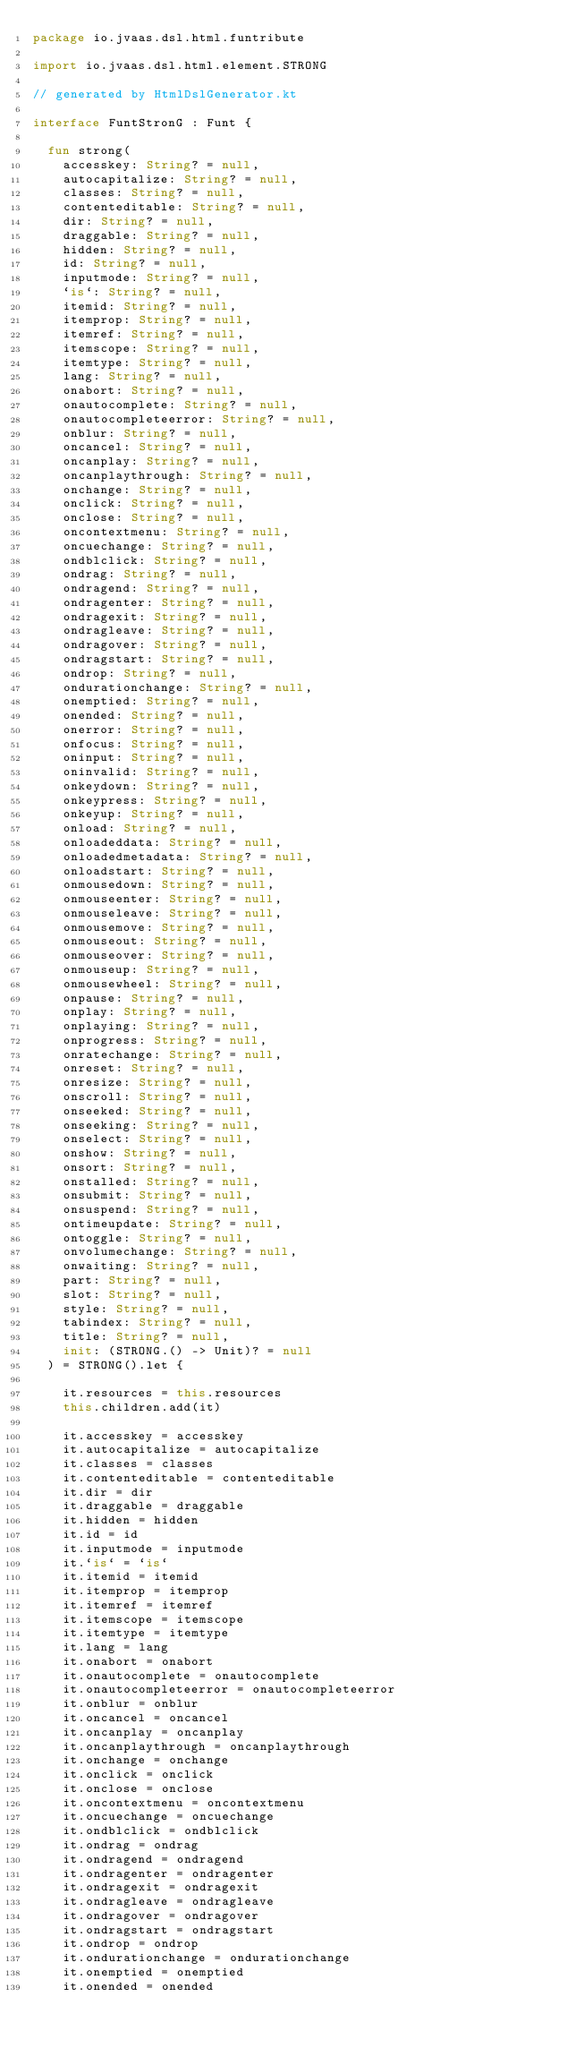Convert code to text. <code><loc_0><loc_0><loc_500><loc_500><_Kotlin_>package io.jvaas.dsl.html.funtribute

import io.jvaas.dsl.html.element.STRONG

// generated by HtmlDslGenerator.kt

interface FuntStronG : Funt {

	fun strong(
		accesskey: String? = null,
		autocapitalize: String? = null,
		classes: String? = null,
		contenteditable: String? = null,
		dir: String? = null,
		draggable: String? = null,
		hidden: String? = null,
		id: String? = null,
		inputmode: String? = null,
		`is`: String? = null,
		itemid: String? = null,
		itemprop: String? = null,
		itemref: String? = null,
		itemscope: String? = null,
		itemtype: String? = null,
		lang: String? = null,
		onabort: String? = null,
		onautocomplete: String? = null,
		onautocompleteerror: String? = null,
		onblur: String? = null,
		oncancel: String? = null,
		oncanplay: String? = null,
		oncanplaythrough: String? = null,
		onchange: String? = null,
		onclick: String? = null,
		onclose: String? = null,
		oncontextmenu: String? = null,
		oncuechange: String? = null,
		ondblclick: String? = null,
		ondrag: String? = null,
		ondragend: String? = null,
		ondragenter: String? = null,
		ondragexit: String? = null,
		ondragleave: String? = null,
		ondragover: String? = null,
		ondragstart: String? = null,
		ondrop: String? = null,
		ondurationchange: String? = null,
		onemptied: String? = null,
		onended: String? = null,
		onerror: String? = null,
		onfocus: String? = null,
		oninput: String? = null,
		oninvalid: String? = null,
		onkeydown: String? = null,
		onkeypress: String? = null,
		onkeyup: String? = null,
		onload: String? = null,
		onloadeddata: String? = null,
		onloadedmetadata: String? = null,
		onloadstart: String? = null,
		onmousedown: String? = null,
		onmouseenter: String? = null,
		onmouseleave: String? = null,
		onmousemove: String? = null,
		onmouseout: String? = null,
		onmouseover: String? = null,
		onmouseup: String? = null,
		onmousewheel: String? = null,
		onpause: String? = null,
		onplay: String? = null,
		onplaying: String? = null,
		onprogress: String? = null,
		onratechange: String? = null,
		onreset: String? = null,
		onresize: String? = null,
		onscroll: String? = null,
		onseeked: String? = null,
		onseeking: String? = null,
		onselect: String? = null,
		onshow: String? = null,
		onsort: String? = null,
		onstalled: String? = null,
		onsubmit: String? = null,
		onsuspend: String? = null,
		ontimeupdate: String? = null,
		ontoggle: String? = null,
		onvolumechange: String? = null,
		onwaiting: String? = null,
		part: String? = null,
		slot: String? = null,
		style: String? = null,
		tabindex: String? = null,
		title: String? = null,
		init: (STRONG.() -> Unit)? = null
	) = STRONG().let {
	
		it.resources = this.resources
		this.children.add(it)
	
		it.accesskey = accesskey
		it.autocapitalize = autocapitalize
		it.classes = classes
		it.contenteditable = contenteditable
		it.dir = dir
		it.draggable = draggable
		it.hidden = hidden
		it.id = id
		it.inputmode = inputmode
		it.`is` = `is`
		it.itemid = itemid
		it.itemprop = itemprop
		it.itemref = itemref
		it.itemscope = itemscope
		it.itemtype = itemtype
		it.lang = lang
		it.onabort = onabort
		it.onautocomplete = onautocomplete
		it.onautocompleteerror = onautocompleteerror
		it.onblur = onblur
		it.oncancel = oncancel
		it.oncanplay = oncanplay
		it.oncanplaythrough = oncanplaythrough
		it.onchange = onchange
		it.onclick = onclick
		it.onclose = onclose
		it.oncontextmenu = oncontextmenu
		it.oncuechange = oncuechange
		it.ondblclick = ondblclick
		it.ondrag = ondrag
		it.ondragend = ondragend
		it.ondragenter = ondragenter
		it.ondragexit = ondragexit
		it.ondragleave = ondragleave
		it.ondragover = ondragover
		it.ondragstart = ondragstart
		it.ondrop = ondrop
		it.ondurationchange = ondurationchange
		it.onemptied = onemptied
		it.onended = onended</code> 